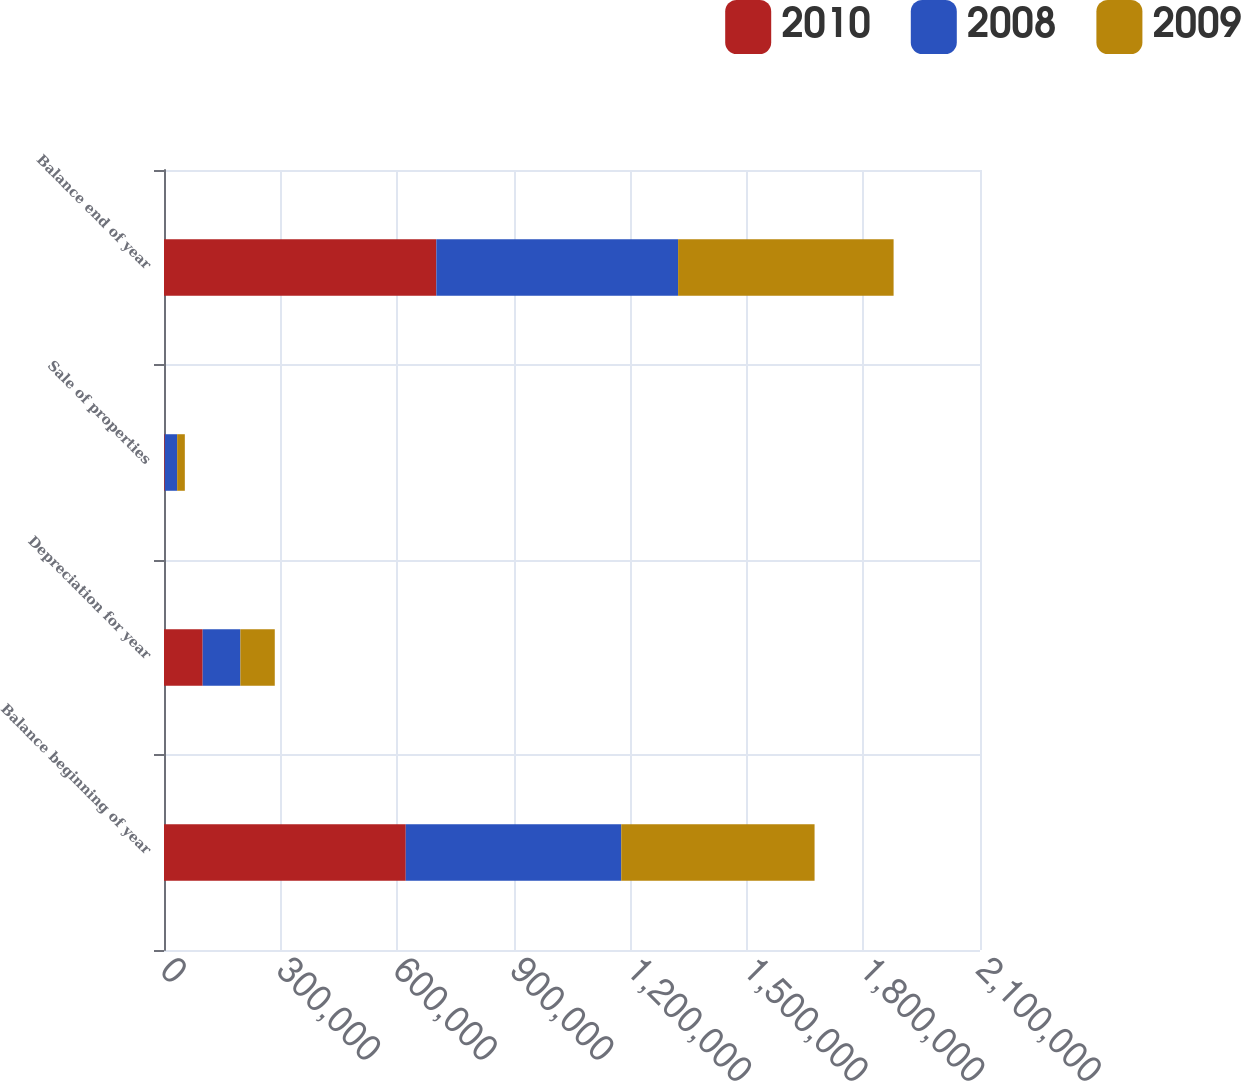Convert chart to OTSL. <chart><loc_0><loc_0><loc_500><loc_500><stacked_bar_chart><ecel><fcel>Balance beginning of year<fcel>Depreciation for year<fcel>Sale of properties<fcel>Balance end of year<nl><fcel>2010<fcel>622163<fcel>99554<fcel>2052<fcel>700878<nl><fcel>2008<fcel>554595<fcel>97019<fcel>31792<fcel>622163<nl><fcel>2009<fcel>497498<fcel>88509<fcel>19771<fcel>554595<nl></chart> 